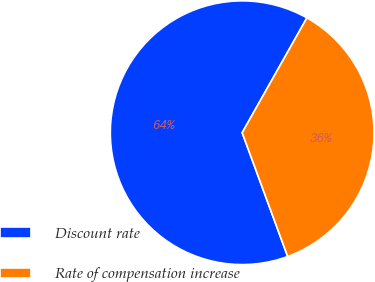Convert chart. <chart><loc_0><loc_0><loc_500><loc_500><pie_chart><fcel>Discount rate<fcel>Rate of compensation increase<nl><fcel>63.77%<fcel>36.23%<nl></chart> 